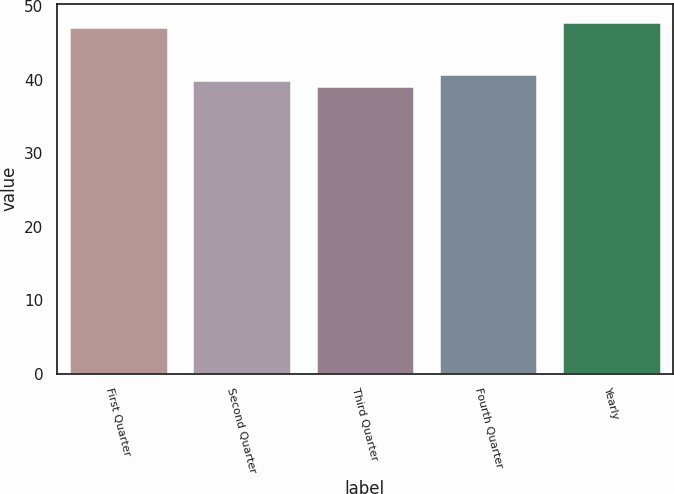Convert chart to OTSL. <chart><loc_0><loc_0><loc_500><loc_500><bar_chart><fcel>First Quarter<fcel>Second Quarter<fcel>Third Quarter<fcel>Fourth Quarter<fcel>Yearly<nl><fcel>47.09<fcel>39.96<fcel>39.06<fcel>40.76<fcel>47.89<nl></chart> 